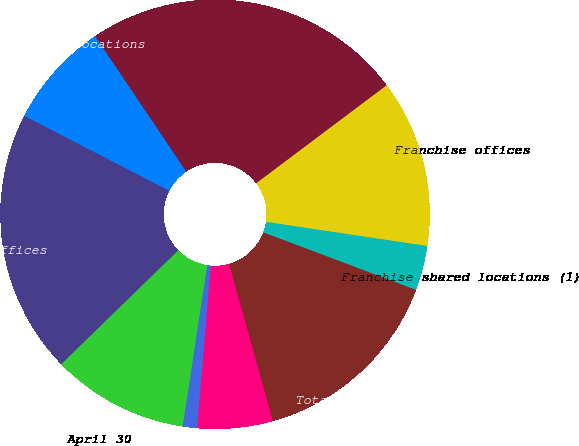<chart> <loc_0><loc_0><loc_500><loc_500><pie_chart><fcel>April 30<fcel>Company-owned offices<fcel>Company-owned shared locations<fcel>Total company-owned offices<fcel>Franchise offices<fcel>Franchise shared locations (1)<fcel>Total franchise offices<fcel>Canada<fcel>Australia<nl><fcel>10.31%<fcel>19.87%<fcel>7.99%<fcel>24.17%<fcel>12.62%<fcel>3.37%<fcel>14.93%<fcel>5.68%<fcel>1.06%<nl></chart> 